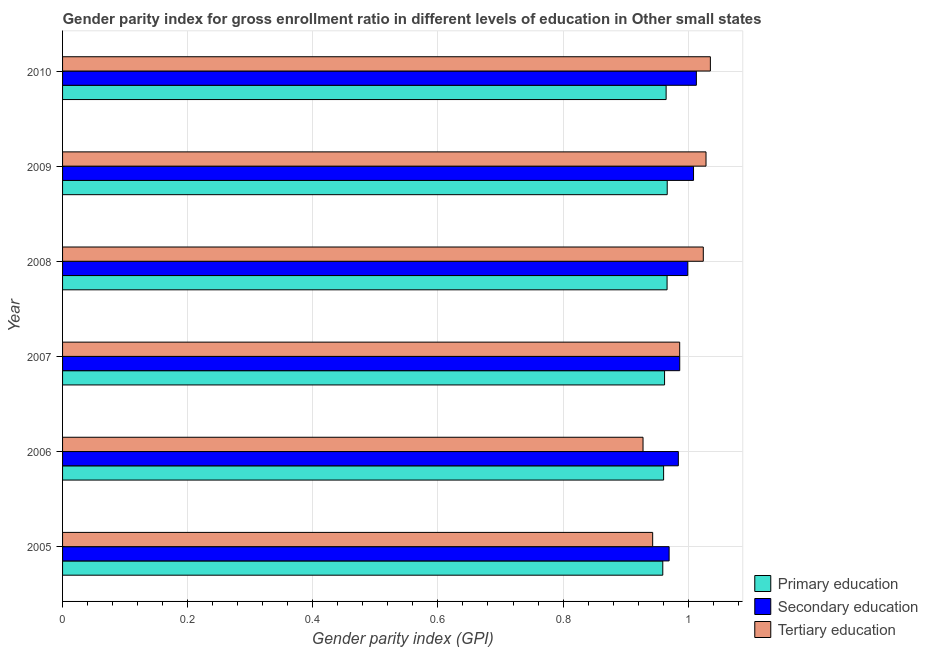How many different coloured bars are there?
Offer a terse response. 3. How many groups of bars are there?
Make the answer very short. 6. Are the number of bars per tick equal to the number of legend labels?
Offer a very short reply. Yes. How many bars are there on the 4th tick from the top?
Provide a succinct answer. 3. What is the label of the 6th group of bars from the top?
Your answer should be very brief. 2005. In how many cases, is the number of bars for a given year not equal to the number of legend labels?
Make the answer very short. 0. What is the gender parity index in secondary education in 2006?
Your response must be concise. 0.98. Across all years, what is the maximum gender parity index in primary education?
Keep it short and to the point. 0.97. Across all years, what is the minimum gender parity index in tertiary education?
Make the answer very short. 0.93. What is the total gender parity index in primary education in the graph?
Your answer should be very brief. 5.78. What is the difference between the gender parity index in primary education in 2006 and that in 2008?
Make the answer very short. -0.01. What is the difference between the gender parity index in secondary education in 2007 and the gender parity index in tertiary education in 2010?
Provide a succinct answer. -0.05. What is the average gender parity index in tertiary education per year?
Your answer should be compact. 0.99. In the year 2010, what is the difference between the gender parity index in tertiary education and gender parity index in secondary education?
Keep it short and to the point. 0.02. What is the ratio of the gender parity index in tertiary education in 2006 to that in 2008?
Offer a terse response. 0.91. Is the gender parity index in tertiary education in 2008 less than that in 2009?
Provide a short and direct response. Yes. What is the difference between the highest and the second highest gender parity index in tertiary education?
Make the answer very short. 0.01. In how many years, is the gender parity index in primary education greater than the average gender parity index in primary education taken over all years?
Keep it short and to the point. 3. Is the sum of the gender parity index in tertiary education in 2008 and 2010 greater than the maximum gender parity index in secondary education across all years?
Your answer should be very brief. Yes. What does the 3rd bar from the bottom in 2006 represents?
Keep it short and to the point. Tertiary education. Is it the case that in every year, the sum of the gender parity index in primary education and gender parity index in secondary education is greater than the gender parity index in tertiary education?
Make the answer very short. Yes. How many bars are there?
Your answer should be very brief. 18. How many years are there in the graph?
Your answer should be compact. 6. Does the graph contain any zero values?
Offer a very short reply. No. Does the graph contain grids?
Offer a terse response. Yes. How many legend labels are there?
Keep it short and to the point. 3. How are the legend labels stacked?
Your answer should be compact. Vertical. What is the title of the graph?
Provide a succinct answer. Gender parity index for gross enrollment ratio in different levels of education in Other small states. What is the label or title of the X-axis?
Make the answer very short. Gender parity index (GPI). What is the Gender parity index (GPI) of Primary education in 2005?
Keep it short and to the point. 0.96. What is the Gender parity index (GPI) of Secondary education in 2005?
Offer a terse response. 0.97. What is the Gender parity index (GPI) of Tertiary education in 2005?
Offer a very short reply. 0.94. What is the Gender parity index (GPI) in Primary education in 2006?
Keep it short and to the point. 0.96. What is the Gender parity index (GPI) of Secondary education in 2006?
Provide a succinct answer. 0.98. What is the Gender parity index (GPI) of Tertiary education in 2006?
Offer a very short reply. 0.93. What is the Gender parity index (GPI) in Primary education in 2007?
Give a very brief answer. 0.96. What is the Gender parity index (GPI) in Secondary education in 2007?
Make the answer very short. 0.99. What is the Gender parity index (GPI) of Tertiary education in 2007?
Your answer should be very brief. 0.99. What is the Gender parity index (GPI) of Primary education in 2008?
Give a very brief answer. 0.97. What is the Gender parity index (GPI) of Secondary education in 2008?
Offer a very short reply. 1. What is the Gender parity index (GPI) in Tertiary education in 2008?
Your answer should be compact. 1.02. What is the Gender parity index (GPI) of Primary education in 2009?
Your response must be concise. 0.97. What is the Gender parity index (GPI) of Secondary education in 2009?
Ensure brevity in your answer.  1.01. What is the Gender parity index (GPI) in Tertiary education in 2009?
Give a very brief answer. 1.03. What is the Gender parity index (GPI) in Primary education in 2010?
Your answer should be compact. 0.96. What is the Gender parity index (GPI) in Secondary education in 2010?
Your response must be concise. 1.01. What is the Gender parity index (GPI) in Tertiary education in 2010?
Provide a short and direct response. 1.04. Across all years, what is the maximum Gender parity index (GPI) in Primary education?
Your answer should be compact. 0.97. Across all years, what is the maximum Gender parity index (GPI) in Secondary education?
Your answer should be compact. 1.01. Across all years, what is the maximum Gender parity index (GPI) of Tertiary education?
Keep it short and to the point. 1.04. Across all years, what is the minimum Gender parity index (GPI) of Primary education?
Your answer should be very brief. 0.96. Across all years, what is the minimum Gender parity index (GPI) of Secondary education?
Keep it short and to the point. 0.97. Across all years, what is the minimum Gender parity index (GPI) of Tertiary education?
Give a very brief answer. 0.93. What is the total Gender parity index (GPI) in Primary education in the graph?
Offer a terse response. 5.78. What is the total Gender parity index (GPI) in Secondary education in the graph?
Ensure brevity in your answer.  5.96. What is the total Gender parity index (GPI) of Tertiary education in the graph?
Offer a very short reply. 5.95. What is the difference between the Gender parity index (GPI) of Primary education in 2005 and that in 2006?
Your answer should be compact. -0. What is the difference between the Gender parity index (GPI) in Secondary education in 2005 and that in 2006?
Ensure brevity in your answer.  -0.01. What is the difference between the Gender parity index (GPI) in Tertiary education in 2005 and that in 2006?
Ensure brevity in your answer.  0.02. What is the difference between the Gender parity index (GPI) in Primary education in 2005 and that in 2007?
Provide a succinct answer. -0. What is the difference between the Gender parity index (GPI) in Secondary education in 2005 and that in 2007?
Offer a very short reply. -0.02. What is the difference between the Gender parity index (GPI) in Tertiary education in 2005 and that in 2007?
Make the answer very short. -0.04. What is the difference between the Gender parity index (GPI) in Primary education in 2005 and that in 2008?
Your answer should be very brief. -0.01. What is the difference between the Gender parity index (GPI) of Secondary education in 2005 and that in 2008?
Your response must be concise. -0.03. What is the difference between the Gender parity index (GPI) in Tertiary education in 2005 and that in 2008?
Offer a terse response. -0.08. What is the difference between the Gender parity index (GPI) of Primary education in 2005 and that in 2009?
Ensure brevity in your answer.  -0.01. What is the difference between the Gender parity index (GPI) in Secondary education in 2005 and that in 2009?
Provide a succinct answer. -0.04. What is the difference between the Gender parity index (GPI) of Tertiary education in 2005 and that in 2009?
Make the answer very short. -0.09. What is the difference between the Gender parity index (GPI) of Primary education in 2005 and that in 2010?
Make the answer very short. -0.01. What is the difference between the Gender parity index (GPI) of Secondary education in 2005 and that in 2010?
Provide a succinct answer. -0.04. What is the difference between the Gender parity index (GPI) of Tertiary education in 2005 and that in 2010?
Provide a succinct answer. -0.09. What is the difference between the Gender parity index (GPI) in Primary education in 2006 and that in 2007?
Provide a short and direct response. -0. What is the difference between the Gender parity index (GPI) in Secondary education in 2006 and that in 2007?
Your answer should be very brief. -0. What is the difference between the Gender parity index (GPI) in Tertiary education in 2006 and that in 2007?
Make the answer very short. -0.06. What is the difference between the Gender parity index (GPI) of Primary education in 2006 and that in 2008?
Keep it short and to the point. -0.01. What is the difference between the Gender parity index (GPI) in Secondary education in 2006 and that in 2008?
Your response must be concise. -0.01. What is the difference between the Gender parity index (GPI) in Tertiary education in 2006 and that in 2008?
Offer a very short reply. -0.1. What is the difference between the Gender parity index (GPI) of Primary education in 2006 and that in 2009?
Provide a short and direct response. -0.01. What is the difference between the Gender parity index (GPI) of Secondary education in 2006 and that in 2009?
Ensure brevity in your answer.  -0.02. What is the difference between the Gender parity index (GPI) of Tertiary education in 2006 and that in 2009?
Make the answer very short. -0.1. What is the difference between the Gender parity index (GPI) in Primary education in 2006 and that in 2010?
Your answer should be very brief. -0. What is the difference between the Gender parity index (GPI) in Secondary education in 2006 and that in 2010?
Keep it short and to the point. -0.03. What is the difference between the Gender parity index (GPI) in Tertiary education in 2006 and that in 2010?
Ensure brevity in your answer.  -0.11. What is the difference between the Gender parity index (GPI) in Primary education in 2007 and that in 2008?
Provide a short and direct response. -0. What is the difference between the Gender parity index (GPI) of Secondary education in 2007 and that in 2008?
Your response must be concise. -0.01. What is the difference between the Gender parity index (GPI) of Tertiary education in 2007 and that in 2008?
Keep it short and to the point. -0.04. What is the difference between the Gender parity index (GPI) in Primary education in 2007 and that in 2009?
Provide a succinct answer. -0. What is the difference between the Gender parity index (GPI) of Secondary education in 2007 and that in 2009?
Keep it short and to the point. -0.02. What is the difference between the Gender parity index (GPI) of Tertiary education in 2007 and that in 2009?
Give a very brief answer. -0.04. What is the difference between the Gender parity index (GPI) in Primary education in 2007 and that in 2010?
Your answer should be very brief. -0. What is the difference between the Gender parity index (GPI) of Secondary education in 2007 and that in 2010?
Give a very brief answer. -0.03. What is the difference between the Gender parity index (GPI) in Tertiary education in 2007 and that in 2010?
Your answer should be compact. -0.05. What is the difference between the Gender parity index (GPI) of Primary education in 2008 and that in 2009?
Offer a terse response. -0. What is the difference between the Gender parity index (GPI) in Secondary education in 2008 and that in 2009?
Offer a very short reply. -0.01. What is the difference between the Gender parity index (GPI) in Tertiary education in 2008 and that in 2009?
Offer a very short reply. -0. What is the difference between the Gender parity index (GPI) of Primary education in 2008 and that in 2010?
Your response must be concise. 0. What is the difference between the Gender parity index (GPI) of Secondary education in 2008 and that in 2010?
Your response must be concise. -0.01. What is the difference between the Gender parity index (GPI) of Tertiary education in 2008 and that in 2010?
Offer a terse response. -0.01. What is the difference between the Gender parity index (GPI) of Primary education in 2009 and that in 2010?
Keep it short and to the point. 0. What is the difference between the Gender parity index (GPI) of Secondary education in 2009 and that in 2010?
Keep it short and to the point. -0. What is the difference between the Gender parity index (GPI) in Tertiary education in 2009 and that in 2010?
Give a very brief answer. -0.01. What is the difference between the Gender parity index (GPI) of Primary education in 2005 and the Gender parity index (GPI) of Secondary education in 2006?
Provide a short and direct response. -0.02. What is the difference between the Gender parity index (GPI) in Primary education in 2005 and the Gender parity index (GPI) in Tertiary education in 2006?
Your response must be concise. 0.03. What is the difference between the Gender parity index (GPI) in Secondary education in 2005 and the Gender parity index (GPI) in Tertiary education in 2006?
Ensure brevity in your answer.  0.04. What is the difference between the Gender parity index (GPI) of Primary education in 2005 and the Gender parity index (GPI) of Secondary education in 2007?
Offer a terse response. -0.03. What is the difference between the Gender parity index (GPI) in Primary education in 2005 and the Gender parity index (GPI) in Tertiary education in 2007?
Your response must be concise. -0.03. What is the difference between the Gender parity index (GPI) in Secondary education in 2005 and the Gender parity index (GPI) in Tertiary education in 2007?
Your response must be concise. -0.02. What is the difference between the Gender parity index (GPI) of Primary education in 2005 and the Gender parity index (GPI) of Secondary education in 2008?
Give a very brief answer. -0.04. What is the difference between the Gender parity index (GPI) of Primary education in 2005 and the Gender parity index (GPI) of Tertiary education in 2008?
Provide a succinct answer. -0.06. What is the difference between the Gender parity index (GPI) of Secondary education in 2005 and the Gender parity index (GPI) of Tertiary education in 2008?
Your response must be concise. -0.05. What is the difference between the Gender parity index (GPI) of Primary education in 2005 and the Gender parity index (GPI) of Secondary education in 2009?
Provide a short and direct response. -0.05. What is the difference between the Gender parity index (GPI) of Primary education in 2005 and the Gender parity index (GPI) of Tertiary education in 2009?
Give a very brief answer. -0.07. What is the difference between the Gender parity index (GPI) of Secondary education in 2005 and the Gender parity index (GPI) of Tertiary education in 2009?
Provide a succinct answer. -0.06. What is the difference between the Gender parity index (GPI) in Primary education in 2005 and the Gender parity index (GPI) in Secondary education in 2010?
Ensure brevity in your answer.  -0.05. What is the difference between the Gender parity index (GPI) in Primary education in 2005 and the Gender parity index (GPI) in Tertiary education in 2010?
Keep it short and to the point. -0.08. What is the difference between the Gender parity index (GPI) in Secondary education in 2005 and the Gender parity index (GPI) in Tertiary education in 2010?
Make the answer very short. -0.07. What is the difference between the Gender parity index (GPI) in Primary education in 2006 and the Gender parity index (GPI) in Secondary education in 2007?
Offer a terse response. -0.03. What is the difference between the Gender parity index (GPI) in Primary education in 2006 and the Gender parity index (GPI) in Tertiary education in 2007?
Your answer should be very brief. -0.03. What is the difference between the Gender parity index (GPI) in Secondary education in 2006 and the Gender parity index (GPI) in Tertiary education in 2007?
Offer a terse response. -0. What is the difference between the Gender parity index (GPI) of Primary education in 2006 and the Gender parity index (GPI) of Secondary education in 2008?
Ensure brevity in your answer.  -0.04. What is the difference between the Gender parity index (GPI) of Primary education in 2006 and the Gender parity index (GPI) of Tertiary education in 2008?
Make the answer very short. -0.06. What is the difference between the Gender parity index (GPI) in Secondary education in 2006 and the Gender parity index (GPI) in Tertiary education in 2008?
Provide a succinct answer. -0.04. What is the difference between the Gender parity index (GPI) in Primary education in 2006 and the Gender parity index (GPI) in Secondary education in 2009?
Offer a terse response. -0.05. What is the difference between the Gender parity index (GPI) in Primary education in 2006 and the Gender parity index (GPI) in Tertiary education in 2009?
Your response must be concise. -0.07. What is the difference between the Gender parity index (GPI) in Secondary education in 2006 and the Gender parity index (GPI) in Tertiary education in 2009?
Your answer should be compact. -0.04. What is the difference between the Gender parity index (GPI) in Primary education in 2006 and the Gender parity index (GPI) in Secondary education in 2010?
Your answer should be very brief. -0.05. What is the difference between the Gender parity index (GPI) in Primary education in 2006 and the Gender parity index (GPI) in Tertiary education in 2010?
Your answer should be very brief. -0.07. What is the difference between the Gender parity index (GPI) in Secondary education in 2006 and the Gender parity index (GPI) in Tertiary education in 2010?
Make the answer very short. -0.05. What is the difference between the Gender parity index (GPI) of Primary education in 2007 and the Gender parity index (GPI) of Secondary education in 2008?
Make the answer very short. -0.04. What is the difference between the Gender parity index (GPI) in Primary education in 2007 and the Gender parity index (GPI) in Tertiary education in 2008?
Offer a terse response. -0.06. What is the difference between the Gender parity index (GPI) in Secondary education in 2007 and the Gender parity index (GPI) in Tertiary education in 2008?
Make the answer very short. -0.04. What is the difference between the Gender parity index (GPI) of Primary education in 2007 and the Gender parity index (GPI) of Secondary education in 2009?
Provide a succinct answer. -0.05. What is the difference between the Gender parity index (GPI) in Primary education in 2007 and the Gender parity index (GPI) in Tertiary education in 2009?
Your answer should be compact. -0.07. What is the difference between the Gender parity index (GPI) in Secondary education in 2007 and the Gender parity index (GPI) in Tertiary education in 2009?
Your answer should be very brief. -0.04. What is the difference between the Gender parity index (GPI) in Primary education in 2007 and the Gender parity index (GPI) in Secondary education in 2010?
Your answer should be very brief. -0.05. What is the difference between the Gender parity index (GPI) of Primary education in 2007 and the Gender parity index (GPI) of Tertiary education in 2010?
Your answer should be very brief. -0.07. What is the difference between the Gender parity index (GPI) of Secondary education in 2007 and the Gender parity index (GPI) of Tertiary education in 2010?
Make the answer very short. -0.05. What is the difference between the Gender parity index (GPI) of Primary education in 2008 and the Gender parity index (GPI) of Secondary education in 2009?
Ensure brevity in your answer.  -0.04. What is the difference between the Gender parity index (GPI) of Primary education in 2008 and the Gender parity index (GPI) of Tertiary education in 2009?
Offer a terse response. -0.06. What is the difference between the Gender parity index (GPI) in Secondary education in 2008 and the Gender parity index (GPI) in Tertiary education in 2009?
Your answer should be compact. -0.03. What is the difference between the Gender parity index (GPI) in Primary education in 2008 and the Gender parity index (GPI) in Secondary education in 2010?
Your response must be concise. -0.05. What is the difference between the Gender parity index (GPI) of Primary education in 2008 and the Gender parity index (GPI) of Tertiary education in 2010?
Your response must be concise. -0.07. What is the difference between the Gender parity index (GPI) of Secondary education in 2008 and the Gender parity index (GPI) of Tertiary education in 2010?
Offer a very short reply. -0.04. What is the difference between the Gender parity index (GPI) of Primary education in 2009 and the Gender parity index (GPI) of Secondary education in 2010?
Your answer should be very brief. -0.05. What is the difference between the Gender parity index (GPI) in Primary education in 2009 and the Gender parity index (GPI) in Tertiary education in 2010?
Your answer should be compact. -0.07. What is the difference between the Gender parity index (GPI) of Secondary education in 2009 and the Gender parity index (GPI) of Tertiary education in 2010?
Provide a short and direct response. -0.03. What is the average Gender parity index (GPI) in Primary education per year?
Ensure brevity in your answer.  0.96. What is the average Gender parity index (GPI) of Secondary education per year?
Keep it short and to the point. 0.99. In the year 2005, what is the difference between the Gender parity index (GPI) of Primary education and Gender parity index (GPI) of Secondary education?
Provide a succinct answer. -0.01. In the year 2005, what is the difference between the Gender parity index (GPI) in Primary education and Gender parity index (GPI) in Tertiary education?
Ensure brevity in your answer.  0.02. In the year 2005, what is the difference between the Gender parity index (GPI) in Secondary education and Gender parity index (GPI) in Tertiary education?
Keep it short and to the point. 0.03. In the year 2006, what is the difference between the Gender parity index (GPI) of Primary education and Gender parity index (GPI) of Secondary education?
Give a very brief answer. -0.02. In the year 2006, what is the difference between the Gender parity index (GPI) in Primary education and Gender parity index (GPI) in Tertiary education?
Provide a succinct answer. 0.03. In the year 2006, what is the difference between the Gender parity index (GPI) in Secondary education and Gender parity index (GPI) in Tertiary education?
Your answer should be compact. 0.06. In the year 2007, what is the difference between the Gender parity index (GPI) of Primary education and Gender parity index (GPI) of Secondary education?
Keep it short and to the point. -0.02. In the year 2007, what is the difference between the Gender parity index (GPI) in Primary education and Gender parity index (GPI) in Tertiary education?
Provide a short and direct response. -0.02. In the year 2007, what is the difference between the Gender parity index (GPI) in Secondary education and Gender parity index (GPI) in Tertiary education?
Your answer should be very brief. 0. In the year 2008, what is the difference between the Gender parity index (GPI) in Primary education and Gender parity index (GPI) in Secondary education?
Provide a short and direct response. -0.03. In the year 2008, what is the difference between the Gender parity index (GPI) of Primary education and Gender parity index (GPI) of Tertiary education?
Provide a short and direct response. -0.06. In the year 2008, what is the difference between the Gender parity index (GPI) of Secondary education and Gender parity index (GPI) of Tertiary education?
Give a very brief answer. -0.02. In the year 2009, what is the difference between the Gender parity index (GPI) in Primary education and Gender parity index (GPI) in Secondary education?
Keep it short and to the point. -0.04. In the year 2009, what is the difference between the Gender parity index (GPI) of Primary education and Gender parity index (GPI) of Tertiary education?
Your response must be concise. -0.06. In the year 2009, what is the difference between the Gender parity index (GPI) in Secondary education and Gender parity index (GPI) in Tertiary education?
Make the answer very short. -0.02. In the year 2010, what is the difference between the Gender parity index (GPI) of Primary education and Gender parity index (GPI) of Secondary education?
Keep it short and to the point. -0.05. In the year 2010, what is the difference between the Gender parity index (GPI) of Primary education and Gender parity index (GPI) of Tertiary education?
Offer a very short reply. -0.07. In the year 2010, what is the difference between the Gender parity index (GPI) in Secondary education and Gender parity index (GPI) in Tertiary education?
Keep it short and to the point. -0.02. What is the ratio of the Gender parity index (GPI) in Secondary education in 2005 to that in 2006?
Your answer should be very brief. 0.98. What is the ratio of the Gender parity index (GPI) in Tertiary education in 2005 to that in 2006?
Your response must be concise. 1.02. What is the ratio of the Gender parity index (GPI) in Primary education in 2005 to that in 2007?
Ensure brevity in your answer.  1. What is the ratio of the Gender parity index (GPI) in Secondary education in 2005 to that in 2007?
Keep it short and to the point. 0.98. What is the ratio of the Gender parity index (GPI) of Tertiary education in 2005 to that in 2007?
Your answer should be compact. 0.96. What is the ratio of the Gender parity index (GPI) in Secondary education in 2005 to that in 2008?
Offer a terse response. 0.97. What is the ratio of the Gender parity index (GPI) in Tertiary education in 2005 to that in 2008?
Give a very brief answer. 0.92. What is the ratio of the Gender parity index (GPI) of Secondary education in 2005 to that in 2009?
Offer a terse response. 0.96. What is the ratio of the Gender parity index (GPI) of Tertiary education in 2005 to that in 2009?
Ensure brevity in your answer.  0.92. What is the ratio of the Gender parity index (GPI) of Secondary education in 2005 to that in 2010?
Give a very brief answer. 0.96. What is the ratio of the Gender parity index (GPI) of Tertiary education in 2005 to that in 2010?
Your response must be concise. 0.91. What is the ratio of the Gender parity index (GPI) of Primary education in 2006 to that in 2007?
Keep it short and to the point. 1. What is the ratio of the Gender parity index (GPI) in Tertiary education in 2006 to that in 2007?
Give a very brief answer. 0.94. What is the ratio of the Gender parity index (GPI) of Secondary education in 2006 to that in 2008?
Offer a terse response. 0.98. What is the ratio of the Gender parity index (GPI) in Tertiary education in 2006 to that in 2008?
Your answer should be very brief. 0.91. What is the ratio of the Gender parity index (GPI) of Primary education in 2006 to that in 2009?
Make the answer very short. 0.99. What is the ratio of the Gender parity index (GPI) of Secondary education in 2006 to that in 2009?
Ensure brevity in your answer.  0.98. What is the ratio of the Gender parity index (GPI) of Tertiary education in 2006 to that in 2009?
Offer a terse response. 0.9. What is the ratio of the Gender parity index (GPI) of Secondary education in 2006 to that in 2010?
Your answer should be compact. 0.97. What is the ratio of the Gender parity index (GPI) of Tertiary education in 2006 to that in 2010?
Your response must be concise. 0.9. What is the ratio of the Gender parity index (GPI) of Primary education in 2007 to that in 2008?
Make the answer very short. 1. What is the ratio of the Gender parity index (GPI) in Secondary education in 2007 to that in 2008?
Your response must be concise. 0.99. What is the ratio of the Gender parity index (GPI) of Tertiary education in 2007 to that in 2008?
Make the answer very short. 0.96. What is the ratio of the Gender parity index (GPI) in Secondary education in 2007 to that in 2009?
Give a very brief answer. 0.98. What is the ratio of the Gender parity index (GPI) of Tertiary education in 2007 to that in 2009?
Provide a succinct answer. 0.96. What is the ratio of the Gender parity index (GPI) in Primary education in 2007 to that in 2010?
Provide a succinct answer. 1. What is the ratio of the Gender parity index (GPI) of Secondary education in 2007 to that in 2010?
Ensure brevity in your answer.  0.97. What is the ratio of the Gender parity index (GPI) in Tertiary education in 2007 to that in 2010?
Provide a succinct answer. 0.95. What is the ratio of the Gender parity index (GPI) of Primary education in 2008 to that in 2009?
Ensure brevity in your answer.  1. What is the ratio of the Gender parity index (GPI) in Secondary education in 2008 to that in 2009?
Offer a very short reply. 0.99. What is the ratio of the Gender parity index (GPI) in Tertiary education in 2008 to that in 2009?
Offer a terse response. 1. What is the ratio of the Gender parity index (GPI) in Secondary education in 2008 to that in 2010?
Offer a terse response. 0.99. What is the ratio of the Gender parity index (GPI) in Tertiary education in 2008 to that in 2010?
Provide a short and direct response. 0.99. What is the ratio of the Gender parity index (GPI) of Tertiary education in 2009 to that in 2010?
Offer a very short reply. 0.99. What is the difference between the highest and the second highest Gender parity index (GPI) in Secondary education?
Offer a terse response. 0. What is the difference between the highest and the second highest Gender parity index (GPI) of Tertiary education?
Provide a short and direct response. 0.01. What is the difference between the highest and the lowest Gender parity index (GPI) of Primary education?
Your response must be concise. 0.01. What is the difference between the highest and the lowest Gender parity index (GPI) of Secondary education?
Provide a succinct answer. 0.04. What is the difference between the highest and the lowest Gender parity index (GPI) in Tertiary education?
Provide a succinct answer. 0.11. 